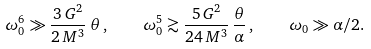<formula> <loc_0><loc_0><loc_500><loc_500>\omega _ { 0 } ^ { 6 } \gg \frac { 3 \, G ^ { 2 } } { 2 \, M ^ { 3 } } \, \theta \, , \quad \omega _ { 0 } ^ { 5 } \gtrsim \frac { 5 \, G ^ { 2 } } { 2 4 \, M ^ { 3 } } \, \frac { \theta } { \alpha } \, , \quad \omega _ { 0 } \gg \alpha / 2 .</formula> 